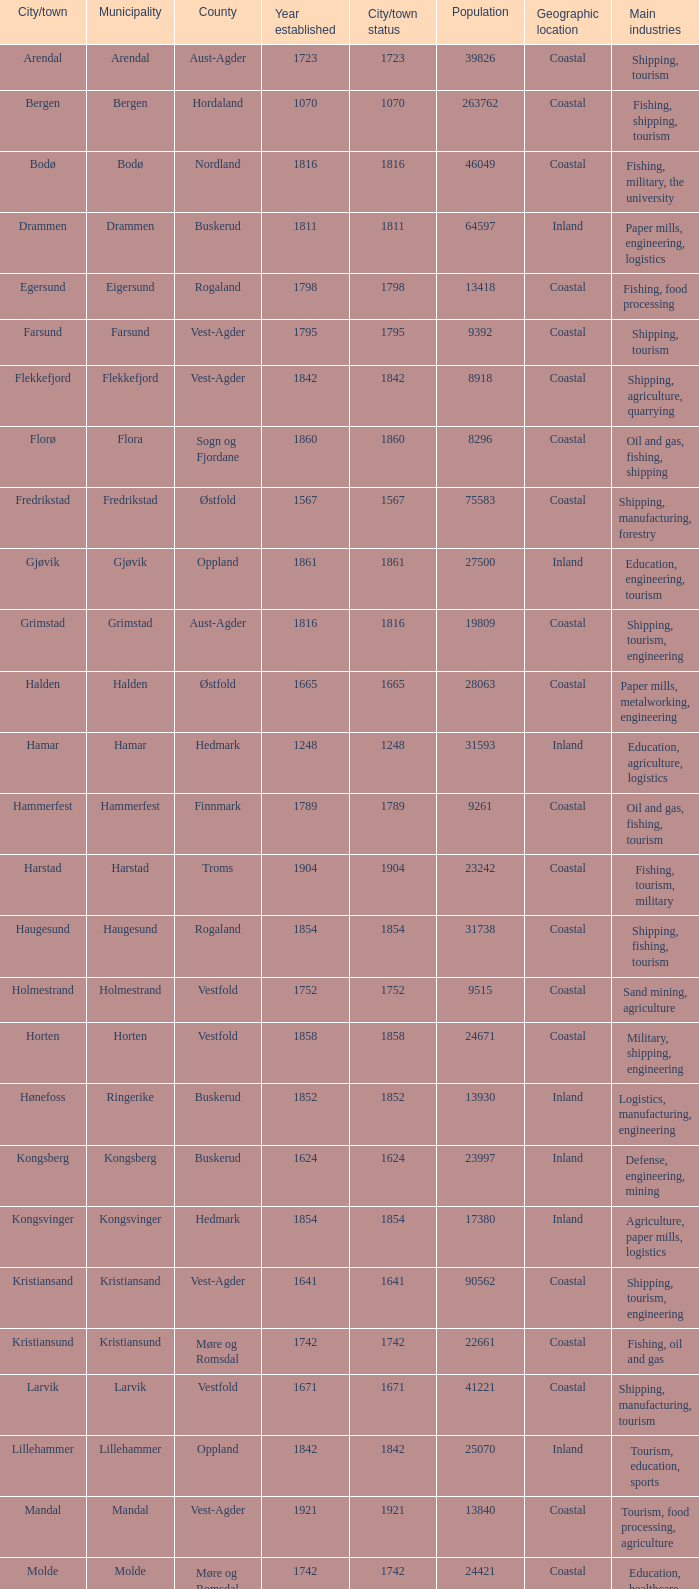Which municipalities located in the county of Finnmark have populations bigger than 6187.0? Hammerfest. 